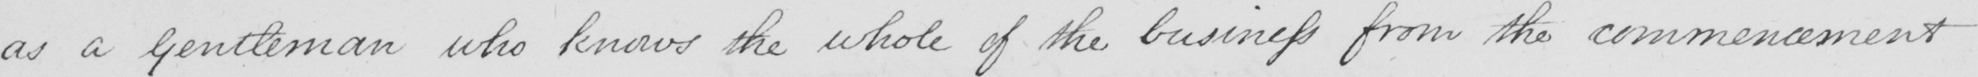Please transcribe the handwritten text in this image. as a Gentleman who knows the whole of the business from the commencement 